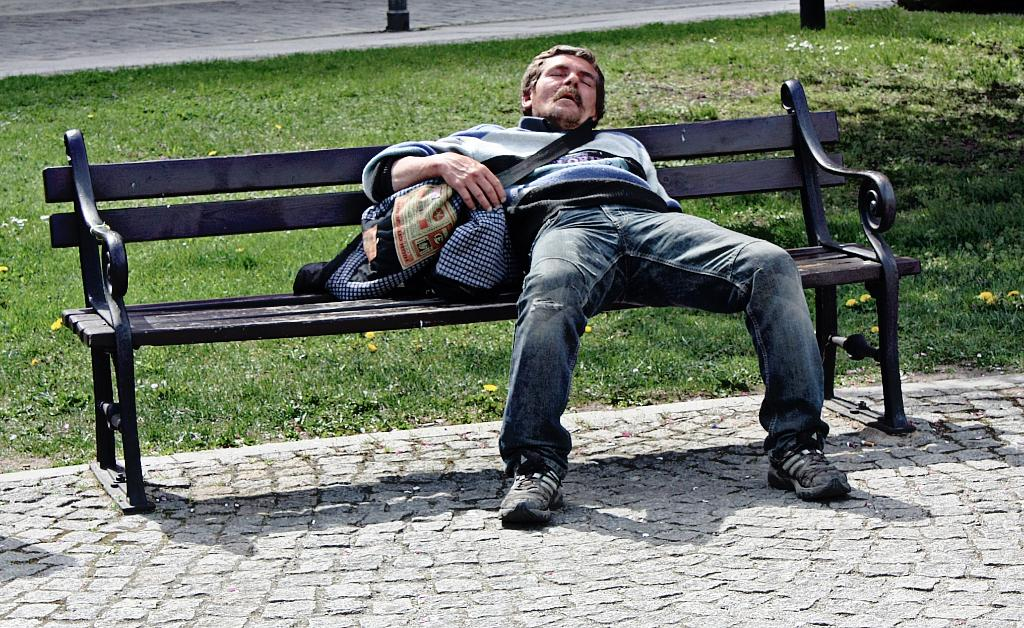What is the person in the image doing? The person is laying on a bench in the image. What color is the bench the person is laying on? The bench is black in color. What is the person holding in their right hand? The person is holding bags in their right hand. What type of natural environment can be seen in the background of the image? There is grass visible in the background of the image. How many houses can be seen in the cellar of the image? There is no cellar or houses present in the image. 